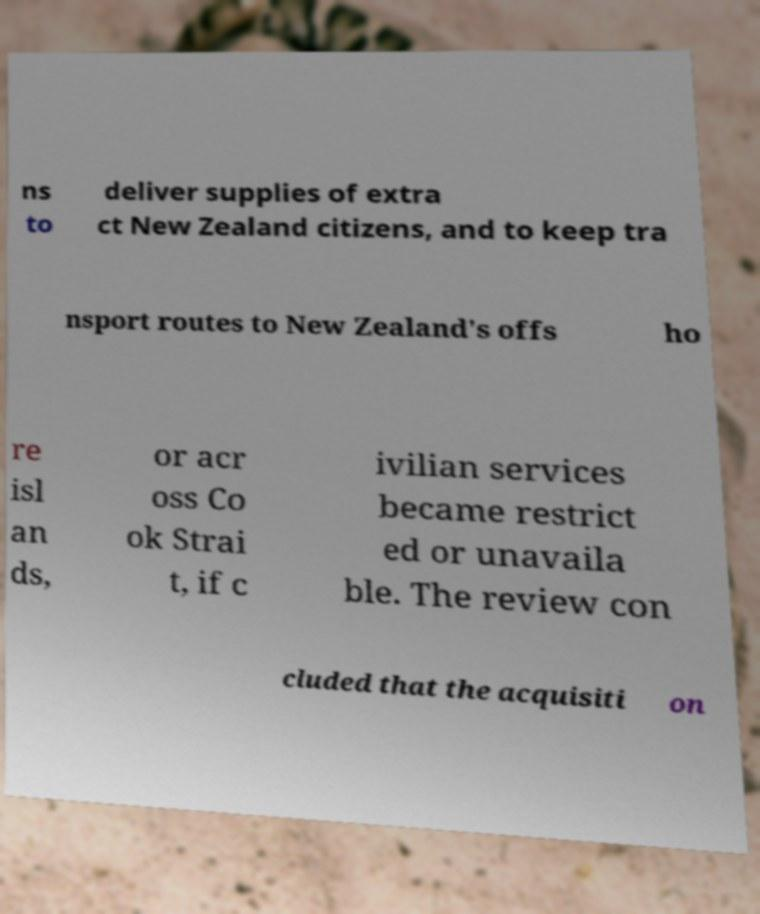Please identify and transcribe the text found in this image. ns to deliver supplies of extra ct New Zealand citizens, and to keep tra nsport routes to New Zealand's offs ho re isl an ds, or acr oss Co ok Strai t, if c ivilian services became restrict ed or unavaila ble. The review con cluded that the acquisiti on 